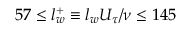Convert formula to latex. <formula><loc_0><loc_0><loc_500><loc_500>5 7 \leq l _ { w } ^ { + } \equiv l _ { w } U _ { \tau } / \nu \leq 1 4 5</formula> 